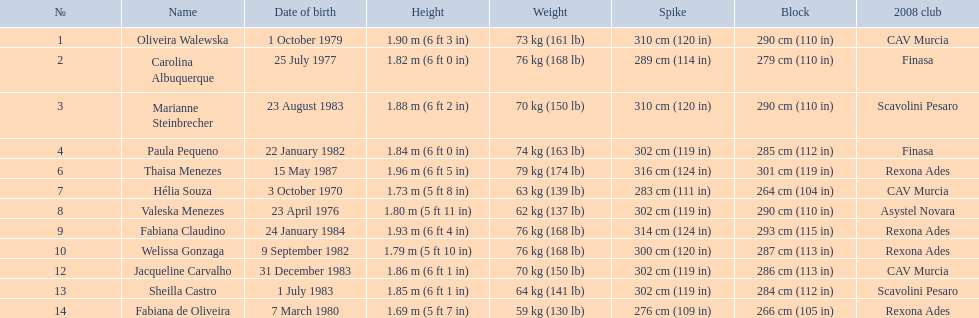How many other competitors have the same block as oliveira walewska? 2. 